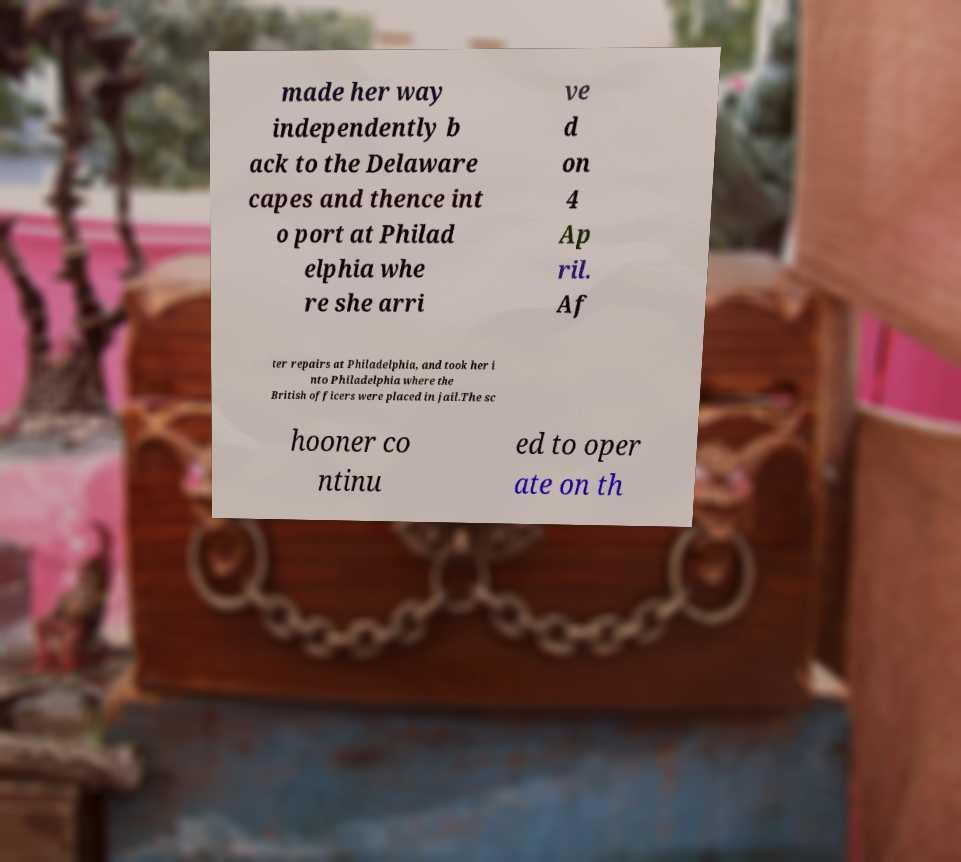What messages or text are displayed in this image? I need them in a readable, typed format. made her way independently b ack to the Delaware capes and thence int o port at Philad elphia whe re she arri ve d on 4 Ap ril. Af ter repairs at Philadelphia, and took her i nto Philadelphia where the British officers were placed in jail.The sc hooner co ntinu ed to oper ate on th 